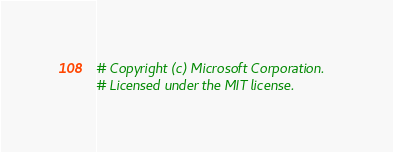Convert code to text. <code><loc_0><loc_0><loc_500><loc_500><_Python_># Copyright (c) Microsoft Corporation.
# Licensed under the MIT license.


</code> 